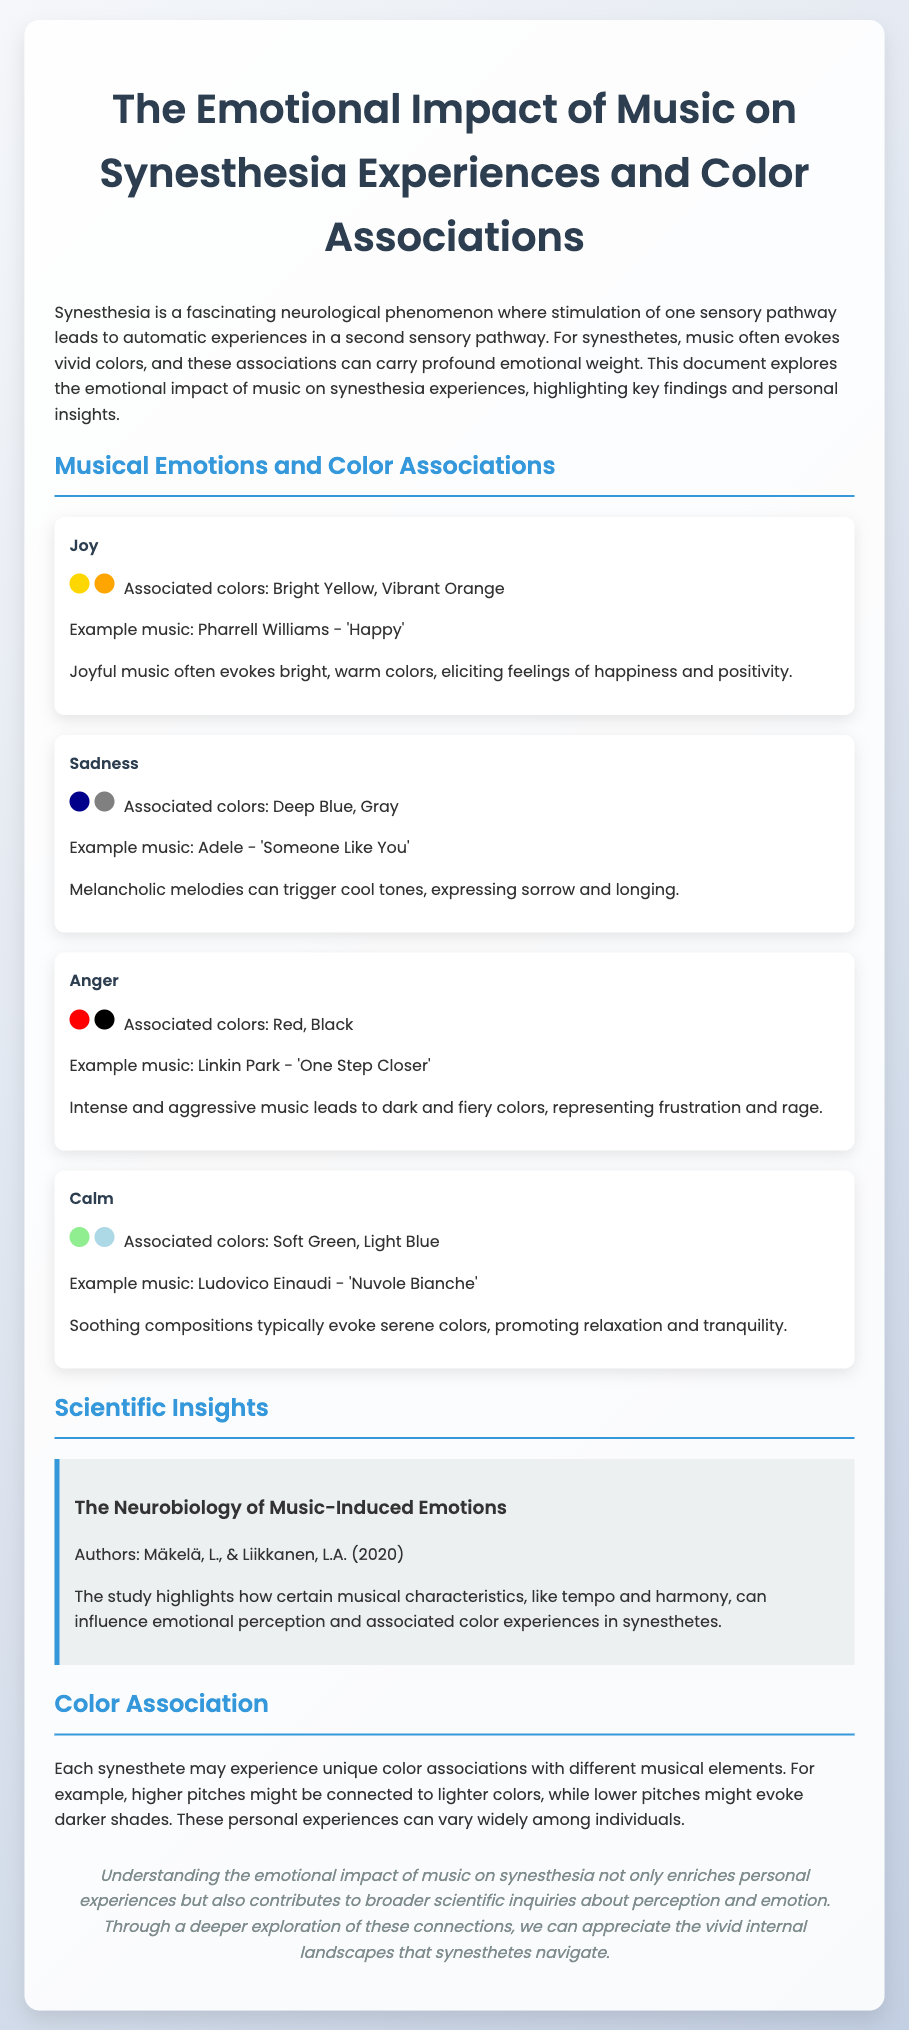what emotion is associated with bright yellow and vibrant orange? Bright yellow and vibrant orange are associated with the emotion of joy in the document.
Answer: joy what example music is linked to sadness? The document provides "Someone Like You" by Adele as an example music linked to sadness.
Answer: Someone Like You which colors are associated with anger? The document states that red and black are the colors associated with anger.
Answer: Red, Black who are the authors of the research study mentioned? The research study mentions the authors Mäkelä and Liikkanen.
Answer: Mäkelä, Liikkanen what is the emotional impact of soothing compositions? The document explains that soothing compositions evoke serene colors, promoting relaxation.
Answer: Promoting relaxation how do higher pitches typically relate to color associations? Higher pitches are connected to lighter colors, as stated in the document.
Answer: Lighter colors what year was the study on music-induced emotions published? The study mentioned in the document was published in the year 2020.
Answer: 2020 which color is associated with calmness? The document indicates that soft green is associated with calmness.
Answer: Soft Green what is a common effect of joyful music on synesthetes? Joyful music often elicits feelings of happiness and positivity, according to the document.
Answer: Happiness and positivity 